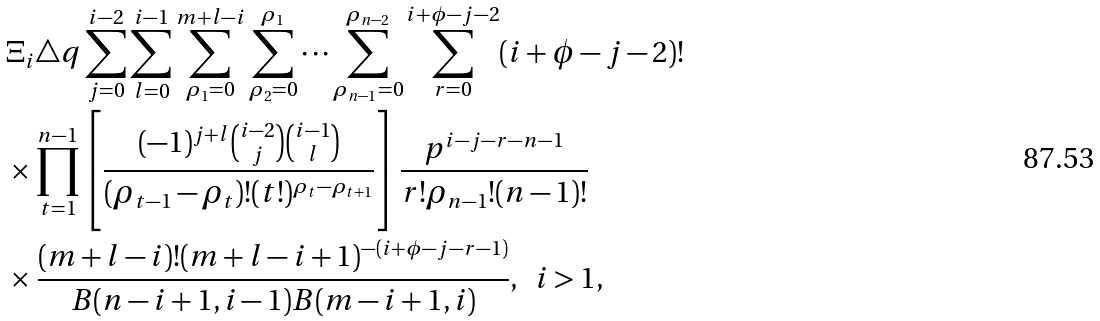<formula> <loc_0><loc_0><loc_500><loc_500>& \Xi _ { i } \triangle q \sum ^ { i - 2 } _ { j = 0 } \sum ^ { i - 1 } _ { l = 0 } \sum ^ { m + l - i } _ { \rho _ { 1 } = 0 } \sum ^ { \rho _ { 1 } } _ { \rho _ { 2 } = 0 } \cdots \sum ^ { \rho _ { n - 2 } } _ { \rho _ { n - 1 } = 0 } \sum ^ { i + \phi - j - 2 } _ { r = 0 } ( i + \phi - j - 2 ) ! \\ & \times \prod ^ { n - 1 } _ { t = 1 } \left [ \frac { ( - 1 ) ^ { j + l } \binom { i - 2 } { j } \binom { i - 1 } { l } } { ( \rho _ { t - 1 } - \rho _ { t } ) ! ( t ! ) ^ { \rho _ { t } - \rho _ { t + 1 } } } \right ] \frac { p ^ { i - j - r - n - 1 } } { r ! \rho _ { n - 1 } ! ( n - 1 ) ! } \\ & \times \frac { ( m + l - i ) ! ( m + l - i + 1 ) ^ { - ( i + \phi - j - r - 1 ) } } { B ( n - i + 1 , i - 1 ) B ( m - i + 1 , i ) } , \ \ i > 1 ,</formula> 